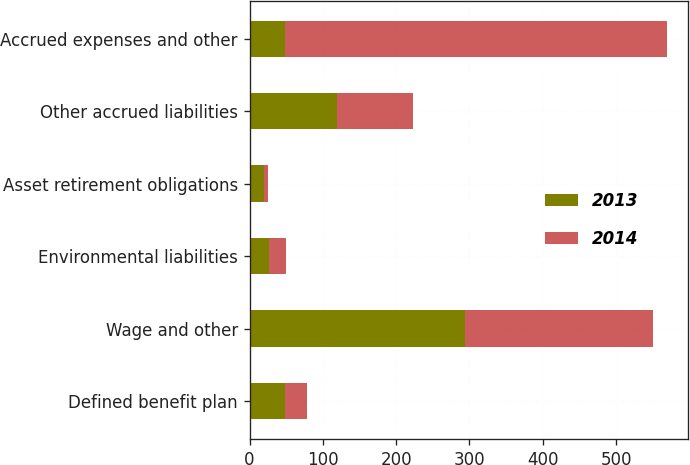Convert chart. <chart><loc_0><loc_0><loc_500><loc_500><stacked_bar_chart><ecel><fcel>Defined benefit plan<fcel>Wage and other<fcel>Environmental liabilities<fcel>Asset retirement obligations<fcel>Other accrued liabilities<fcel>Accrued expenses and other<nl><fcel>2013<fcel>48<fcel>294<fcel>26<fcel>20<fcel>120<fcel>48<nl><fcel>2014<fcel>30<fcel>257<fcel>24<fcel>5<fcel>103<fcel>522<nl></chart> 